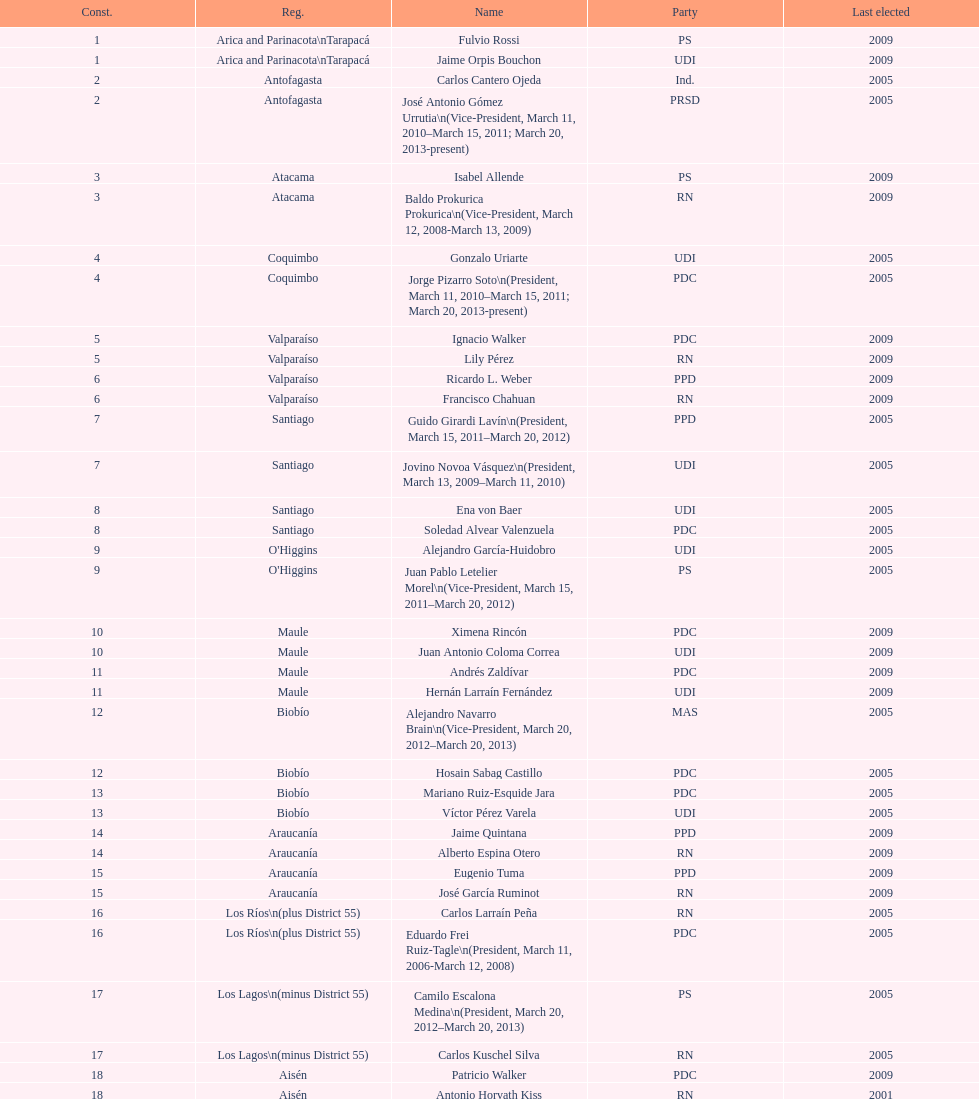Who was not last elected in either 2005 or 2009? Antonio Horvath Kiss. 